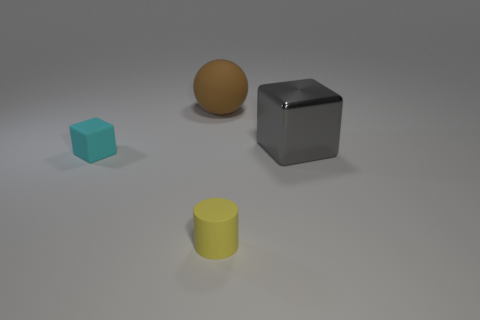What material is the small cyan thing that is the same shape as the big gray shiny thing?
Make the answer very short. Rubber. The object that is right of the brown rubber sphere and behind the small yellow rubber thing is made of what material?
Give a very brief answer. Metal. What shape is the tiny cyan thing that is the same material as the tiny cylinder?
Provide a short and direct response. Cube. What number of rubber objects are behind the tiny cyan matte cube and in front of the tiny cyan object?
Provide a short and direct response. 0. There is a thing in front of the cyan matte block; what is its size?
Your response must be concise. Small. There is a thing in front of the small rubber object that is behind the yellow object; what is its material?
Your response must be concise. Rubber. Is the color of the thing that is in front of the matte cube the same as the matte sphere?
Provide a succinct answer. No. What number of tiny matte things are the same shape as the large gray metallic object?
Your answer should be very brief. 1. The cyan object that is the same material as the tiny yellow cylinder is what size?
Ensure brevity in your answer.  Small. There is a object that is to the left of the thing behind the metallic cube; are there any small rubber blocks that are in front of it?
Your response must be concise. No. 